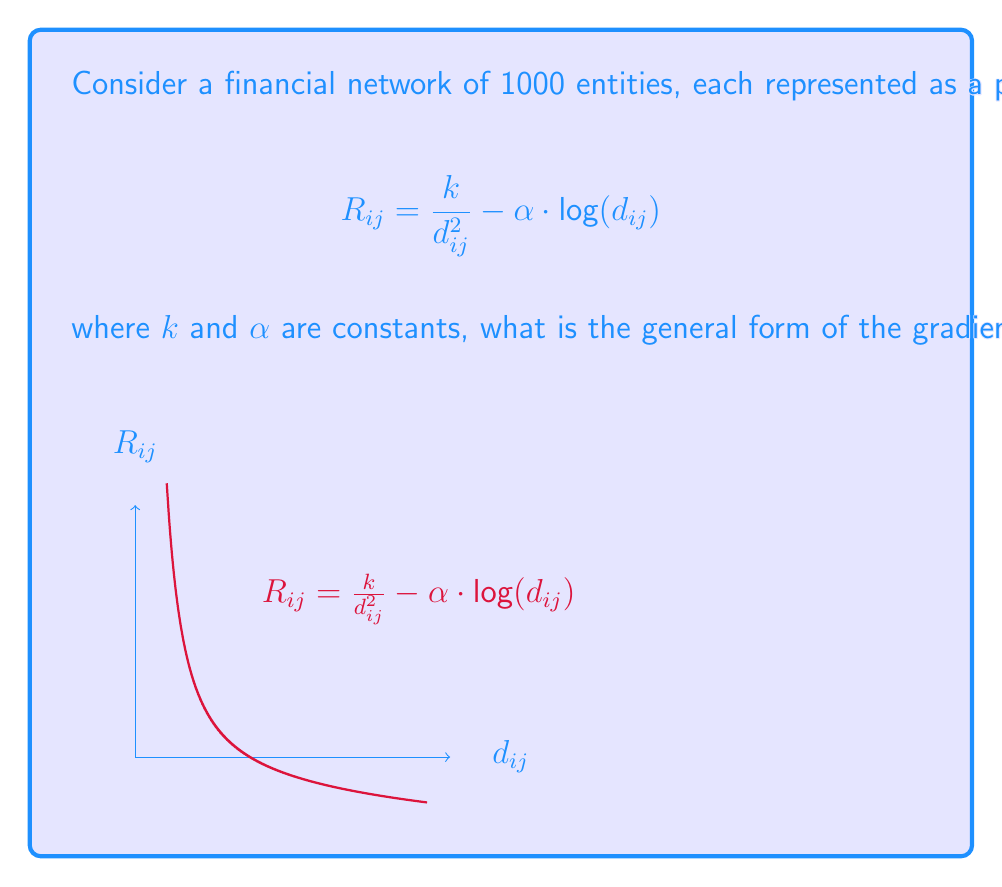What is the answer to this math problem? To find the gradient of $R_{ij}$ with respect to the coordinates on $\mathcal{M}$, we need to follow these steps:

1) First, recall that $R_{ij}$ is a function of the geodesic distance $d_{ij}$:

   $$R_{ij} = \frac{k}{d_{ij}^2} - \alpha \cdot \text{log}(d_{ij})$$

2) By the chain rule, we can express the gradient of $R_{ij}$ as:

   $$\nabla R_{ij} = \frac{\partial R_{ij}}{\partial d_{ij}} \cdot \nabla d_{ij}$$

3) Let's calculate $\frac{\partial R_{ij}}{\partial d_{ij}}$:

   $$\frac{\partial R_{ij}}{\partial d_{ij}} = -\frac{2k}{d_{ij}^3} - \frac{\alpha}{d_{ij}}$$

4) Now, $\nabla d_{ij}$ is the gradient of the geodesic distance function on the manifold $\mathcal{M}$. In general, for a point $p$ on a Riemannian manifold, the gradient of the distance function from a fixed point $q$ is given by:

   $$\nabla d(p,q) = -\exp_p^{-1}(q)$$

   where $\exp_p^{-1}$ is the inverse of the exponential map at $p$.

5) Combining steps 3 and 4, we get:

   $$\nabla R_{ij} = \left(-\frac{2k}{d_{ij}^3} - \frac{\alpha}{d_{ij}}\right) \cdot (-\exp_p^{-1}(q))$$

6) Simplifying:

   $$\nabla R_{ij} = \left(\frac{2k}{d_{ij}^3} + \frac{\alpha}{d_{ij}}\right) \cdot \exp_p^{-1}(q)$$

This is the general form of the gradient of $R_{ij}$ with respect to the coordinates on $\mathcal{M}$.
Answer: $$\nabla R_{ij} = \left(\frac{2k}{d_{ij}^3} + \frac{\alpha}{d_{ij}}\right) \cdot \exp_p^{-1}(q)$$ 